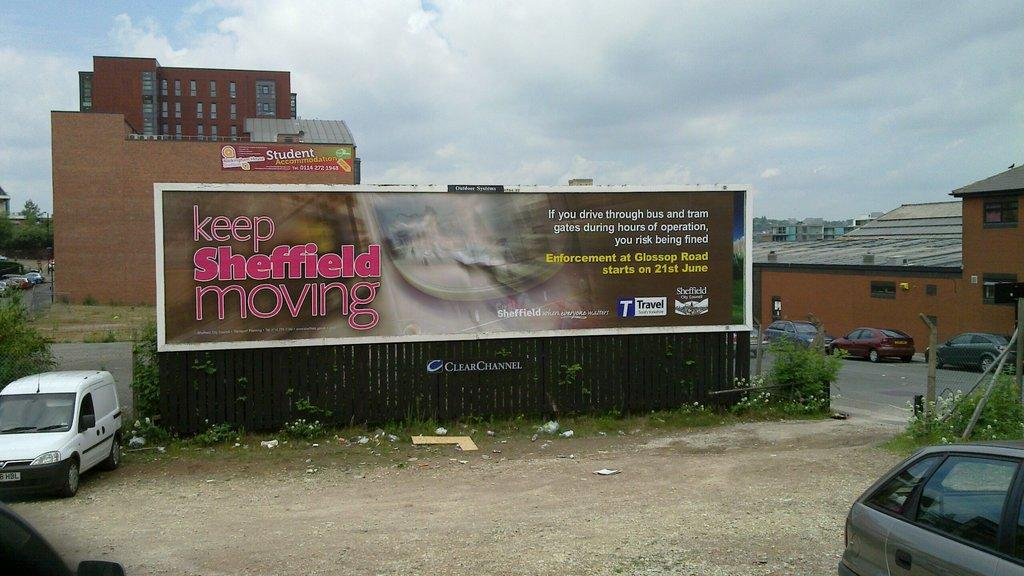<image>
Write a terse but informative summary of the picture. A billboard suggests that we keep Sheffield moving. 